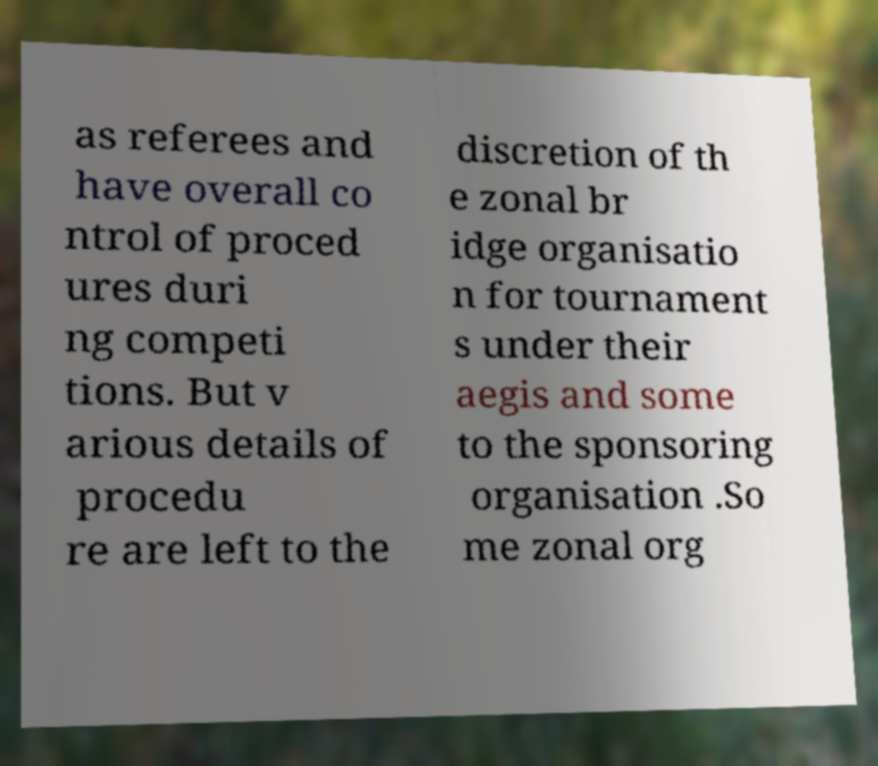Please read and relay the text visible in this image. What does it say? as referees and have overall co ntrol of proced ures duri ng competi tions. But v arious details of procedu re are left to the discretion of th e zonal br idge organisatio n for tournament s under their aegis and some to the sponsoring organisation .So me zonal org 